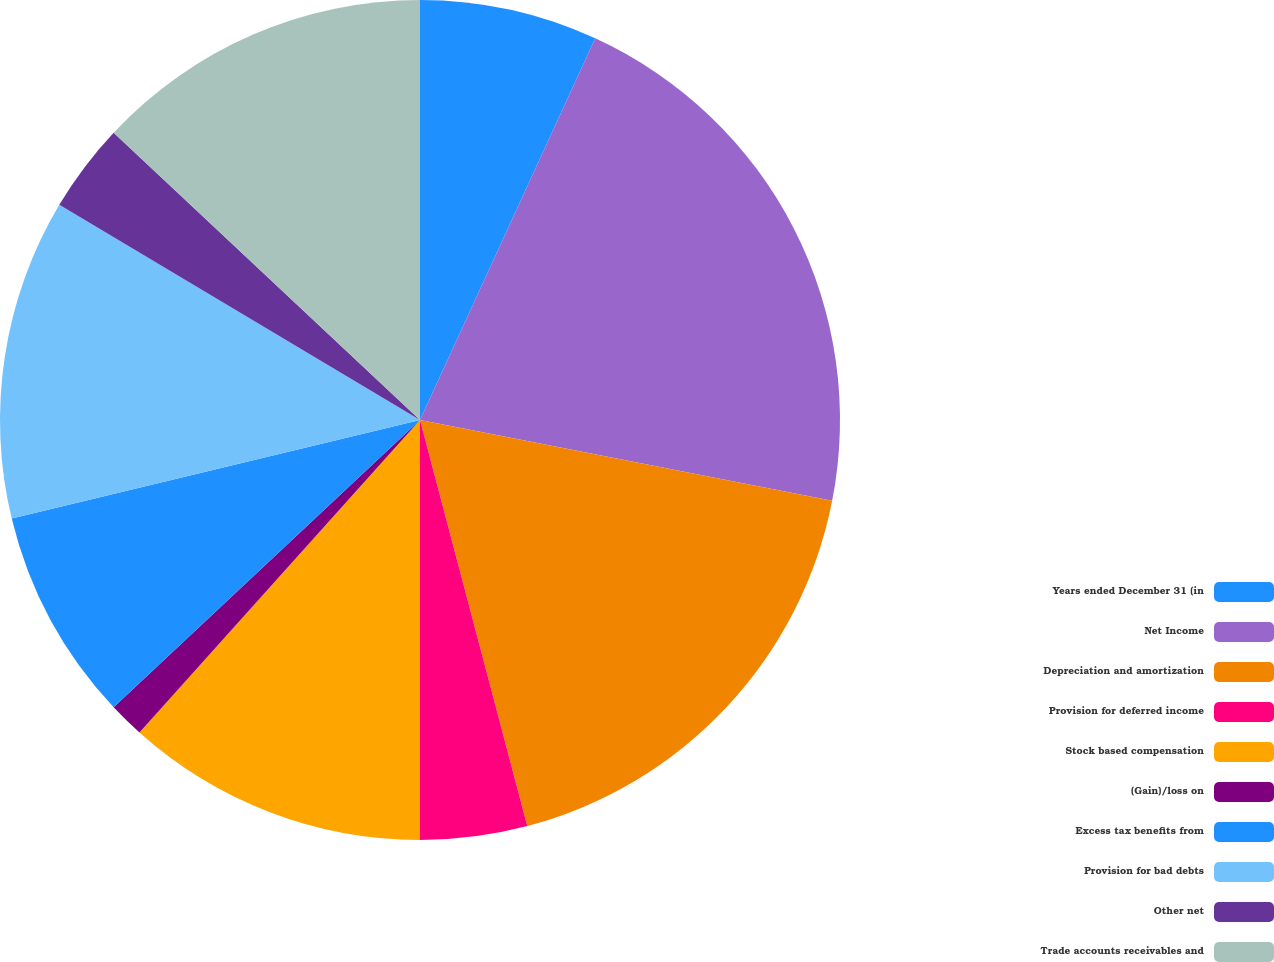Convert chart. <chart><loc_0><loc_0><loc_500><loc_500><pie_chart><fcel>Years ended December 31 (in<fcel>Net Income<fcel>Depreciation and amortization<fcel>Provision for deferred income<fcel>Stock based compensation<fcel>(Gain)/loss on<fcel>Excess tax benefits from<fcel>Provision for bad debts<fcel>Other net<fcel>Trade accounts receivables and<nl><fcel>6.85%<fcel>21.23%<fcel>17.81%<fcel>4.11%<fcel>11.64%<fcel>1.37%<fcel>8.22%<fcel>12.33%<fcel>3.43%<fcel>13.01%<nl></chart> 